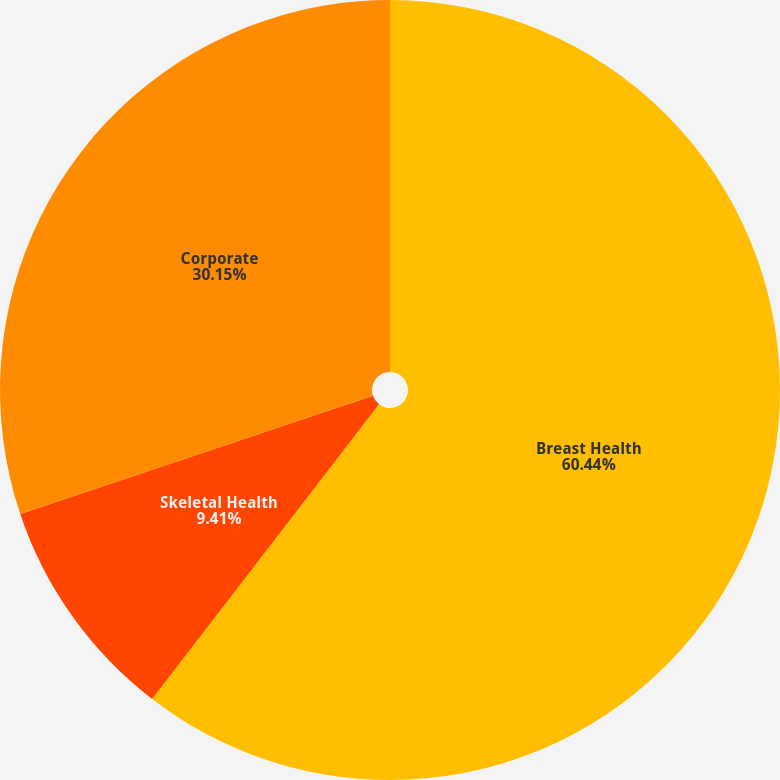<chart> <loc_0><loc_0><loc_500><loc_500><pie_chart><fcel>Breast Health<fcel>Skeletal Health<fcel>Corporate<nl><fcel>60.44%<fcel>9.41%<fcel>30.15%<nl></chart> 